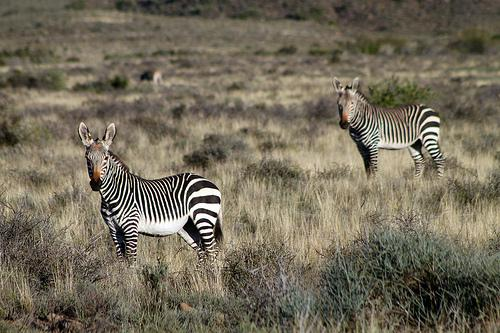How many zebras are in the image and what are their main colors? There are two zebras in the image, primarily black and white with some brown markings. Is there any object that stands out in this image, if so, what? Yes, there is a green safari shrub that stands out against the brown grass and zebras. What is the weather like in this image? The weather appears to be sunny, as suggested by the light and shadows in the scene. Enumerate the notable features of the zebras. Stripes, brown markings, pointy ears, black hair on their tails, white stomachs, long legs. Mention the key elements in the scene and their respective positions. Two zebras - left and right side; tall brown grass - all around; green shrubs - background. What is the primary focus of this image? The primary focus of the image is the two zebras standing amidst a grassy field. What kind of landscape is depicted in the image? A sunny safari scenery with tall dry grass, green shrubs, and two zebras in the field. Provide a summary of the contents of the image in 10-15 words. Two zebras standing on a grass field, surrounded by tall brown grass and green shrubs. Offer a single-sentence description that captures the mood of the image. A serene moment in the sun-drenched safari, as two zebras stand amongst the tall grass and shrubs. Can you describe the sizes of the zebras by comparing their heights and widths? The left zebra is taller and wider, while the right zebra is smaller with a narrower stance. Notice the group of wild horses galloping across the field. The provided data only talks about zebras, grass, and shrubs. There are no horses, wild or otherwise, mentioned as being present in the image. There is a bird perched on the branches of a tree. No such object is mentioned in the data provided. All objects referred to in the image involve zebras, grass, and shrubs. There is no mention of trees or birds within the available information. Can you see the distant mountain range in the background? There are no mentions of mountains or any other such scenery in the provided data. All objects mentioned are focused on the zebras, shrubs, and grass in the image. Could you please identify the sprawling tree in the center of the image? There is no mention of a tree in the center of the image within the given data. All mentioned objects relate to zebras, grass, and shrubs, but no tree is mentioned. Examine the blue sky spread above the landscape. There is no mention of the sky in the data provided. All objects indicated in the image are focused on the zebras, shrubs, and grass, with no reference to the sky. Look for the lion silently stalking the zebras. There is no mention of any lion (or any other animal besides zebras) within the given data. All objects within the image pertain only to zebras, grass, and shrubs. 